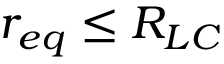<formula> <loc_0><loc_0><loc_500><loc_500>r _ { e q } \leq R _ { L C }</formula> 